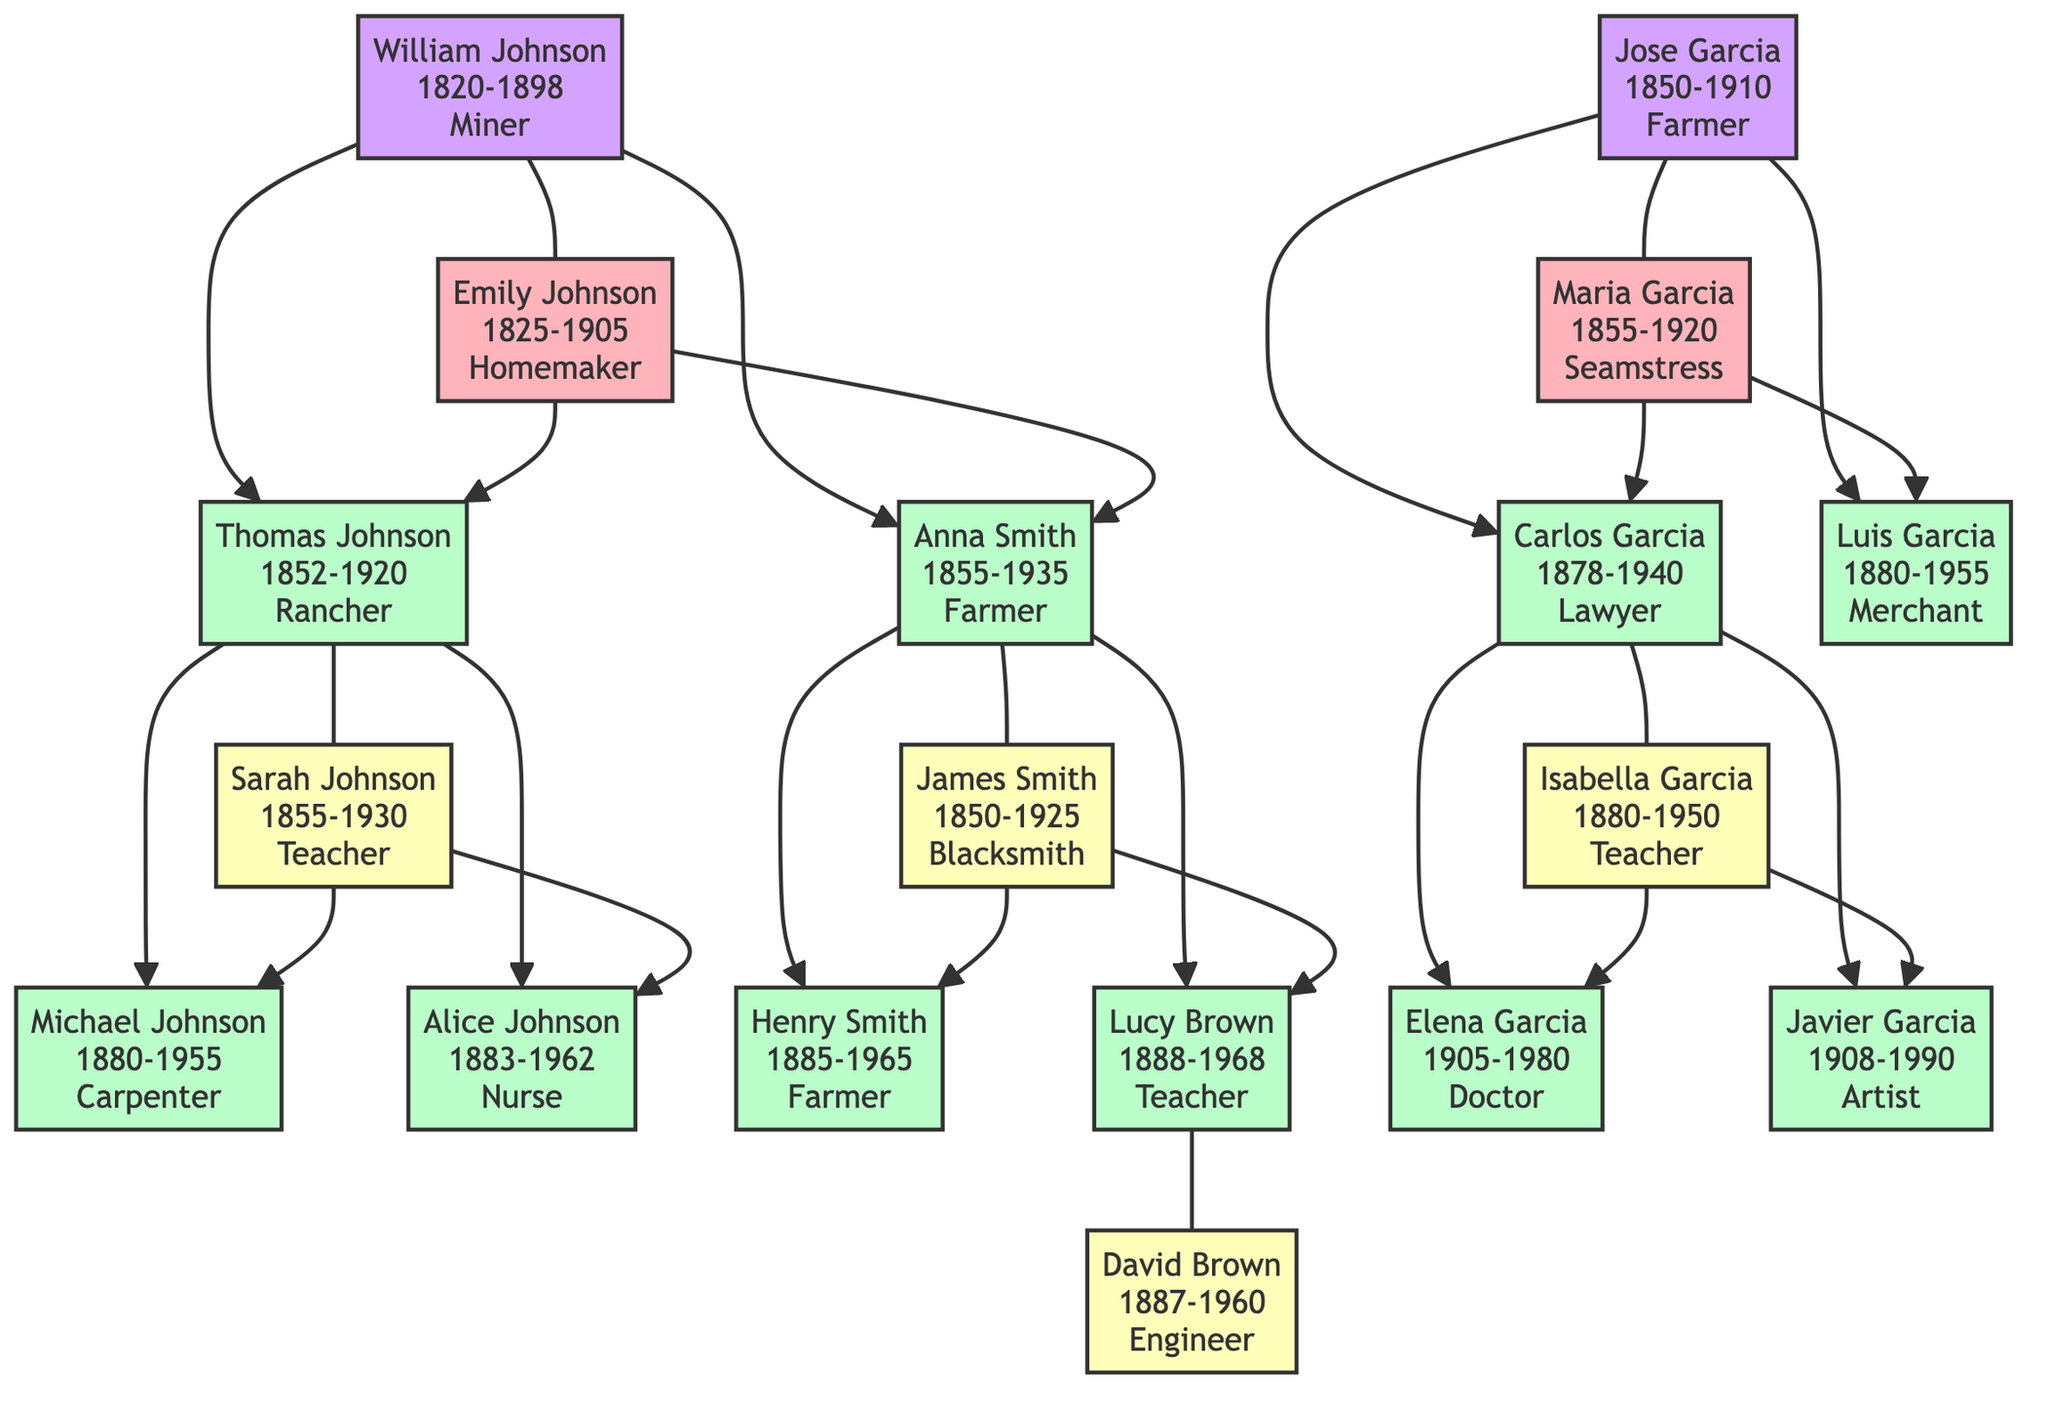What year did the Johnson family settle? The Johnson family settled in 1850, which is indicated in the family tree under the "settlement year" designation.
Answer: 1850 How many children did William and Emily Johnson have? William and Emily Johnson had two children, Thomas and Anna, which can be seen in the connections stemming from them in the diagram.
Answer: 2 Who was the matriarch of the Garcia family? The matriarch of the Garcia family is Maria Garcia, as listed in the family tree alongside Jose Garcia, the patriarch.
Answer: Maria Garcia What was the occupation of Thomas Johnson? Thomas Johnson's occupation is listed as Rancher in the family tree, which is directly indicated near his name.
Answer: Rancher How many grandchildren did William and Emily Johnson have? William and Emily Johnson had four grandchildren: Michael, Alice, Henry, and Lucy. This is determined by counting the children of their two offspring, Thomas and Anna.
Answer: 4 Which family settled in 1880? The Garcia family settled in 1880, as noted under "settlement year" for that family in the diagram.
Answer: Garcia Family What was the occupation of Anna Smith's spouse? Anna Smith's spouse, James Smith, was a Blacksmith. This information can be found next to James's name in the family tree.
Answer: Blacksmith Who was the oldest child of the Garcia family? The oldest child of the Garcia family is Carlos Garcia, born in 1878. This can be confirmed by looking at the birth years of the children listed for the Garcia family.
Answer: Carlos Garcia Which occupation is common to the Johnson family children? The common occupation among the children of the Johnson family is teaching, specifically for Sarah Johnson and Lucy Brown. This is discerned from their listed careers adjacent to their names.
Answer: Teacher 